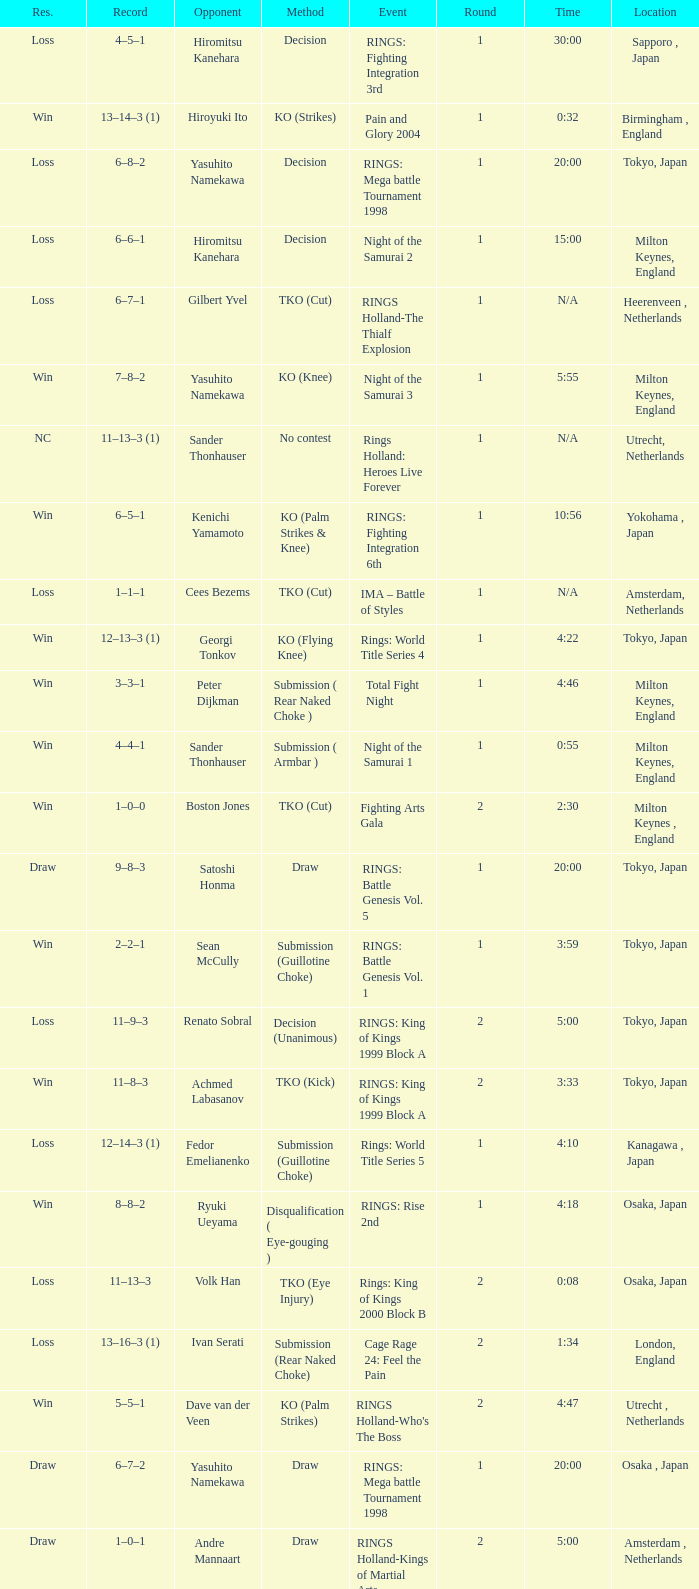Who was the opponent in London, England in a round less than 2? Mario Sperry. 